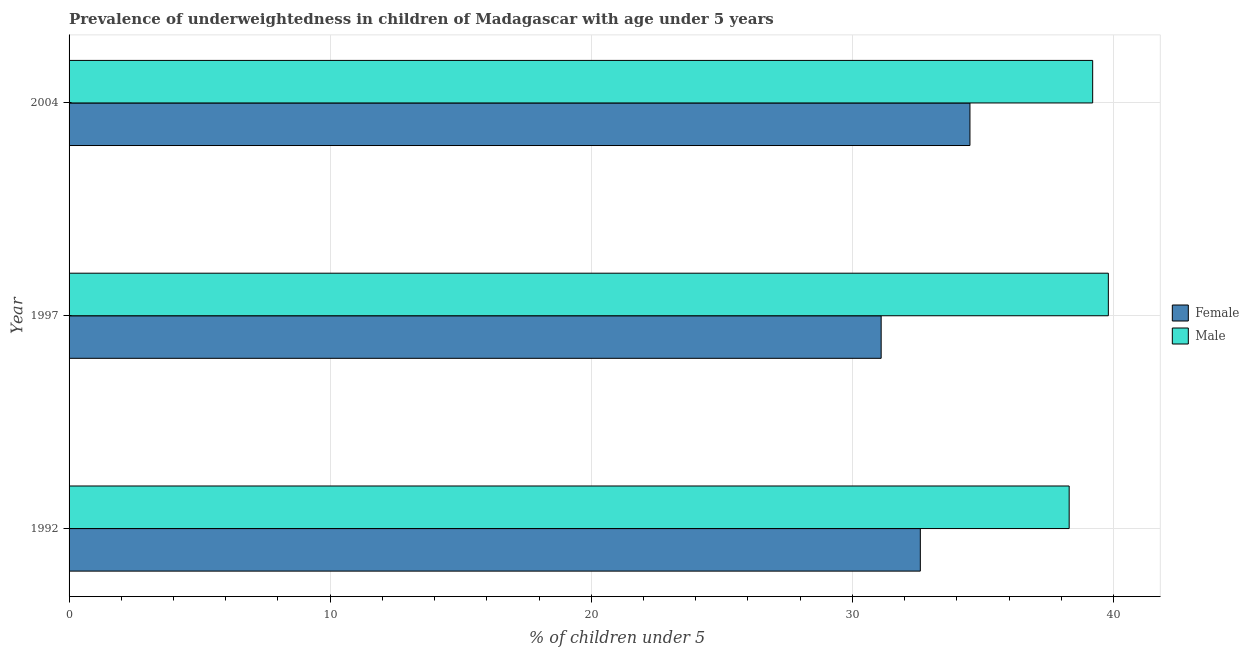Are the number of bars per tick equal to the number of legend labels?
Ensure brevity in your answer.  Yes. Are the number of bars on each tick of the Y-axis equal?
Provide a short and direct response. Yes. What is the label of the 1st group of bars from the top?
Provide a succinct answer. 2004. What is the percentage of underweighted female children in 1997?
Keep it short and to the point. 31.1. Across all years, what is the maximum percentage of underweighted male children?
Provide a short and direct response. 39.8. Across all years, what is the minimum percentage of underweighted male children?
Your answer should be compact. 38.3. What is the total percentage of underweighted female children in the graph?
Give a very brief answer. 98.2. What is the difference between the percentage of underweighted female children in 1997 and the percentage of underweighted male children in 2004?
Provide a succinct answer. -8.1. What is the average percentage of underweighted female children per year?
Provide a succinct answer. 32.73. Is the percentage of underweighted female children in 1992 less than that in 2004?
Give a very brief answer. Yes. Is the difference between the percentage of underweighted female children in 1992 and 1997 greater than the difference between the percentage of underweighted male children in 1992 and 1997?
Offer a terse response. Yes. What is the difference between the highest and the second highest percentage of underweighted female children?
Your response must be concise. 1.9. In how many years, is the percentage of underweighted female children greater than the average percentage of underweighted female children taken over all years?
Keep it short and to the point. 1. Is the sum of the percentage of underweighted male children in 1992 and 1997 greater than the maximum percentage of underweighted female children across all years?
Provide a succinct answer. Yes. What does the 1st bar from the bottom in 2004 represents?
Keep it short and to the point. Female. Are the values on the major ticks of X-axis written in scientific E-notation?
Your answer should be very brief. No. How many legend labels are there?
Make the answer very short. 2. What is the title of the graph?
Ensure brevity in your answer.  Prevalence of underweightedness in children of Madagascar with age under 5 years. What is the label or title of the X-axis?
Keep it short and to the point.  % of children under 5. What is the  % of children under 5 in Female in 1992?
Offer a very short reply. 32.6. What is the  % of children under 5 in Male in 1992?
Give a very brief answer. 38.3. What is the  % of children under 5 in Female in 1997?
Your response must be concise. 31.1. What is the  % of children under 5 of Male in 1997?
Offer a terse response. 39.8. What is the  % of children under 5 of Female in 2004?
Ensure brevity in your answer.  34.5. What is the  % of children under 5 in Male in 2004?
Offer a terse response. 39.2. Across all years, what is the maximum  % of children under 5 in Female?
Offer a very short reply. 34.5. Across all years, what is the maximum  % of children under 5 of Male?
Your answer should be compact. 39.8. Across all years, what is the minimum  % of children under 5 in Female?
Offer a very short reply. 31.1. Across all years, what is the minimum  % of children under 5 in Male?
Provide a short and direct response. 38.3. What is the total  % of children under 5 of Female in the graph?
Provide a succinct answer. 98.2. What is the total  % of children under 5 in Male in the graph?
Your response must be concise. 117.3. What is the difference between the  % of children under 5 of Female in 1992 and that in 1997?
Ensure brevity in your answer.  1.5. What is the difference between the  % of children under 5 of Male in 1992 and that in 1997?
Your answer should be very brief. -1.5. What is the difference between the  % of children under 5 of Female in 1992 and that in 2004?
Provide a short and direct response. -1.9. What is the difference between the  % of children under 5 of Male in 1997 and that in 2004?
Keep it short and to the point. 0.6. What is the difference between the  % of children under 5 of Female in 1992 and the  % of children under 5 of Male in 1997?
Give a very brief answer. -7.2. What is the average  % of children under 5 of Female per year?
Ensure brevity in your answer.  32.73. What is the average  % of children under 5 in Male per year?
Your answer should be compact. 39.1. In the year 1992, what is the difference between the  % of children under 5 in Female and  % of children under 5 in Male?
Offer a very short reply. -5.7. What is the ratio of the  % of children under 5 in Female in 1992 to that in 1997?
Offer a terse response. 1.05. What is the ratio of the  % of children under 5 in Male in 1992 to that in 1997?
Your answer should be compact. 0.96. What is the ratio of the  % of children under 5 in Female in 1992 to that in 2004?
Make the answer very short. 0.94. What is the ratio of the  % of children under 5 of Female in 1997 to that in 2004?
Provide a short and direct response. 0.9. What is the ratio of the  % of children under 5 of Male in 1997 to that in 2004?
Make the answer very short. 1.02. What is the difference between the highest and the lowest  % of children under 5 of Female?
Keep it short and to the point. 3.4. What is the difference between the highest and the lowest  % of children under 5 in Male?
Your answer should be very brief. 1.5. 